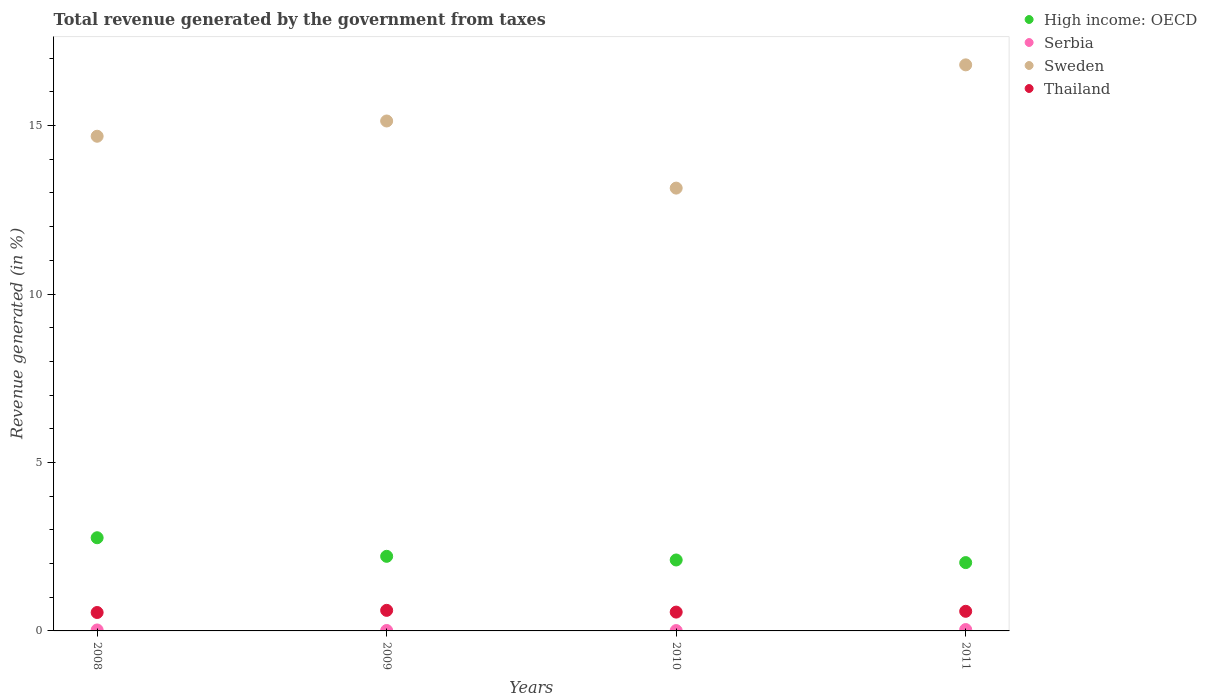How many different coloured dotlines are there?
Ensure brevity in your answer.  4. Is the number of dotlines equal to the number of legend labels?
Provide a succinct answer. Yes. What is the total revenue generated in High income: OECD in 2008?
Keep it short and to the point. 2.77. Across all years, what is the maximum total revenue generated in Thailand?
Ensure brevity in your answer.  0.61. Across all years, what is the minimum total revenue generated in Thailand?
Make the answer very short. 0.55. In which year was the total revenue generated in Thailand minimum?
Provide a short and direct response. 2008. What is the total total revenue generated in Thailand in the graph?
Keep it short and to the point. 2.3. What is the difference between the total revenue generated in Thailand in 2008 and that in 2009?
Your answer should be very brief. -0.06. What is the difference between the total revenue generated in Sweden in 2009 and the total revenue generated in Serbia in 2010?
Provide a short and direct response. 15.13. What is the average total revenue generated in High income: OECD per year?
Make the answer very short. 2.28. In the year 2011, what is the difference between the total revenue generated in Serbia and total revenue generated in Sweden?
Your answer should be compact. -16.76. In how many years, is the total revenue generated in Thailand greater than 10 %?
Give a very brief answer. 0. What is the ratio of the total revenue generated in Serbia in 2010 to that in 2011?
Your response must be concise. 0.26. Is the total revenue generated in Serbia in 2008 less than that in 2011?
Offer a very short reply. Yes. Is the difference between the total revenue generated in Serbia in 2008 and 2009 greater than the difference between the total revenue generated in Sweden in 2008 and 2009?
Provide a short and direct response. Yes. What is the difference between the highest and the second highest total revenue generated in Sweden?
Your response must be concise. 1.67. What is the difference between the highest and the lowest total revenue generated in High income: OECD?
Keep it short and to the point. 0.74. Is the sum of the total revenue generated in Serbia in 2008 and 2010 greater than the maximum total revenue generated in Thailand across all years?
Provide a short and direct response. No. Does the total revenue generated in Thailand monotonically increase over the years?
Your response must be concise. No. Is the total revenue generated in Sweden strictly greater than the total revenue generated in Thailand over the years?
Offer a very short reply. Yes. Is the total revenue generated in Serbia strictly less than the total revenue generated in Thailand over the years?
Make the answer very short. Yes. How many dotlines are there?
Make the answer very short. 4. Does the graph contain grids?
Provide a short and direct response. No. Where does the legend appear in the graph?
Make the answer very short. Top right. What is the title of the graph?
Provide a succinct answer. Total revenue generated by the government from taxes. What is the label or title of the X-axis?
Make the answer very short. Years. What is the label or title of the Y-axis?
Your answer should be very brief. Revenue generated (in %). What is the Revenue generated (in %) of High income: OECD in 2008?
Provide a short and direct response. 2.77. What is the Revenue generated (in %) of Serbia in 2008?
Make the answer very short. 0.03. What is the Revenue generated (in %) in Sweden in 2008?
Your answer should be very brief. 14.68. What is the Revenue generated (in %) in Thailand in 2008?
Provide a short and direct response. 0.55. What is the Revenue generated (in %) in High income: OECD in 2009?
Your answer should be very brief. 2.21. What is the Revenue generated (in %) in Serbia in 2009?
Your answer should be compact. 0.01. What is the Revenue generated (in %) in Sweden in 2009?
Your answer should be compact. 15.14. What is the Revenue generated (in %) of Thailand in 2009?
Keep it short and to the point. 0.61. What is the Revenue generated (in %) in High income: OECD in 2010?
Make the answer very short. 2.11. What is the Revenue generated (in %) in Serbia in 2010?
Your response must be concise. 0.01. What is the Revenue generated (in %) of Sweden in 2010?
Your answer should be compact. 13.14. What is the Revenue generated (in %) in Thailand in 2010?
Make the answer very short. 0.56. What is the Revenue generated (in %) in High income: OECD in 2011?
Give a very brief answer. 2.03. What is the Revenue generated (in %) in Serbia in 2011?
Make the answer very short. 0.04. What is the Revenue generated (in %) in Sweden in 2011?
Your answer should be compact. 16.8. What is the Revenue generated (in %) in Thailand in 2011?
Your response must be concise. 0.58. Across all years, what is the maximum Revenue generated (in %) in High income: OECD?
Provide a short and direct response. 2.77. Across all years, what is the maximum Revenue generated (in %) in Serbia?
Give a very brief answer. 0.04. Across all years, what is the maximum Revenue generated (in %) in Sweden?
Your answer should be compact. 16.8. Across all years, what is the maximum Revenue generated (in %) of Thailand?
Your response must be concise. 0.61. Across all years, what is the minimum Revenue generated (in %) of High income: OECD?
Provide a short and direct response. 2.03. Across all years, what is the minimum Revenue generated (in %) in Serbia?
Keep it short and to the point. 0.01. Across all years, what is the minimum Revenue generated (in %) of Sweden?
Ensure brevity in your answer.  13.14. Across all years, what is the minimum Revenue generated (in %) of Thailand?
Ensure brevity in your answer.  0.55. What is the total Revenue generated (in %) of High income: OECD in the graph?
Ensure brevity in your answer.  9.11. What is the total Revenue generated (in %) in Serbia in the graph?
Give a very brief answer. 0.09. What is the total Revenue generated (in %) of Sweden in the graph?
Keep it short and to the point. 59.76. What is the total Revenue generated (in %) of Thailand in the graph?
Offer a terse response. 2.3. What is the difference between the Revenue generated (in %) of High income: OECD in 2008 and that in 2009?
Your answer should be very brief. 0.55. What is the difference between the Revenue generated (in %) in Serbia in 2008 and that in 2009?
Offer a very short reply. 0.02. What is the difference between the Revenue generated (in %) of Sweden in 2008 and that in 2009?
Offer a terse response. -0.45. What is the difference between the Revenue generated (in %) of Thailand in 2008 and that in 2009?
Provide a short and direct response. -0.06. What is the difference between the Revenue generated (in %) in High income: OECD in 2008 and that in 2010?
Your answer should be very brief. 0.66. What is the difference between the Revenue generated (in %) in Serbia in 2008 and that in 2010?
Your response must be concise. 0.02. What is the difference between the Revenue generated (in %) in Sweden in 2008 and that in 2010?
Your response must be concise. 1.54. What is the difference between the Revenue generated (in %) of Thailand in 2008 and that in 2010?
Your answer should be very brief. -0.01. What is the difference between the Revenue generated (in %) in High income: OECD in 2008 and that in 2011?
Give a very brief answer. 0.74. What is the difference between the Revenue generated (in %) of Serbia in 2008 and that in 2011?
Give a very brief answer. -0.01. What is the difference between the Revenue generated (in %) of Sweden in 2008 and that in 2011?
Provide a succinct answer. -2.12. What is the difference between the Revenue generated (in %) in Thailand in 2008 and that in 2011?
Provide a short and direct response. -0.04. What is the difference between the Revenue generated (in %) in High income: OECD in 2009 and that in 2010?
Provide a succinct answer. 0.11. What is the difference between the Revenue generated (in %) of Serbia in 2009 and that in 2010?
Your answer should be compact. 0. What is the difference between the Revenue generated (in %) in Sweden in 2009 and that in 2010?
Your response must be concise. 1.99. What is the difference between the Revenue generated (in %) in Thailand in 2009 and that in 2010?
Your answer should be compact. 0.05. What is the difference between the Revenue generated (in %) of High income: OECD in 2009 and that in 2011?
Offer a very short reply. 0.19. What is the difference between the Revenue generated (in %) in Serbia in 2009 and that in 2011?
Your answer should be very brief. -0.03. What is the difference between the Revenue generated (in %) of Sweden in 2009 and that in 2011?
Offer a terse response. -1.67. What is the difference between the Revenue generated (in %) of Thailand in 2009 and that in 2011?
Your answer should be very brief. 0.03. What is the difference between the Revenue generated (in %) in High income: OECD in 2010 and that in 2011?
Provide a succinct answer. 0.08. What is the difference between the Revenue generated (in %) of Serbia in 2010 and that in 2011?
Make the answer very short. -0.03. What is the difference between the Revenue generated (in %) of Sweden in 2010 and that in 2011?
Keep it short and to the point. -3.66. What is the difference between the Revenue generated (in %) of Thailand in 2010 and that in 2011?
Make the answer very short. -0.02. What is the difference between the Revenue generated (in %) in High income: OECD in 2008 and the Revenue generated (in %) in Serbia in 2009?
Your answer should be very brief. 2.75. What is the difference between the Revenue generated (in %) of High income: OECD in 2008 and the Revenue generated (in %) of Sweden in 2009?
Keep it short and to the point. -12.37. What is the difference between the Revenue generated (in %) of High income: OECD in 2008 and the Revenue generated (in %) of Thailand in 2009?
Offer a very short reply. 2.16. What is the difference between the Revenue generated (in %) of Serbia in 2008 and the Revenue generated (in %) of Sweden in 2009?
Make the answer very short. -15.11. What is the difference between the Revenue generated (in %) of Serbia in 2008 and the Revenue generated (in %) of Thailand in 2009?
Make the answer very short. -0.58. What is the difference between the Revenue generated (in %) of Sweden in 2008 and the Revenue generated (in %) of Thailand in 2009?
Keep it short and to the point. 14.07. What is the difference between the Revenue generated (in %) of High income: OECD in 2008 and the Revenue generated (in %) of Serbia in 2010?
Give a very brief answer. 2.76. What is the difference between the Revenue generated (in %) of High income: OECD in 2008 and the Revenue generated (in %) of Sweden in 2010?
Keep it short and to the point. -10.38. What is the difference between the Revenue generated (in %) in High income: OECD in 2008 and the Revenue generated (in %) in Thailand in 2010?
Give a very brief answer. 2.21. What is the difference between the Revenue generated (in %) of Serbia in 2008 and the Revenue generated (in %) of Sweden in 2010?
Give a very brief answer. -13.12. What is the difference between the Revenue generated (in %) in Serbia in 2008 and the Revenue generated (in %) in Thailand in 2010?
Keep it short and to the point. -0.53. What is the difference between the Revenue generated (in %) of Sweden in 2008 and the Revenue generated (in %) of Thailand in 2010?
Give a very brief answer. 14.12. What is the difference between the Revenue generated (in %) in High income: OECD in 2008 and the Revenue generated (in %) in Serbia in 2011?
Offer a terse response. 2.73. What is the difference between the Revenue generated (in %) of High income: OECD in 2008 and the Revenue generated (in %) of Sweden in 2011?
Provide a succinct answer. -14.04. What is the difference between the Revenue generated (in %) of High income: OECD in 2008 and the Revenue generated (in %) of Thailand in 2011?
Make the answer very short. 2.18. What is the difference between the Revenue generated (in %) in Serbia in 2008 and the Revenue generated (in %) in Sweden in 2011?
Provide a short and direct response. -16.77. What is the difference between the Revenue generated (in %) in Serbia in 2008 and the Revenue generated (in %) in Thailand in 2011?
Provide a short and direct response. -0.55. What is the difference between the Revenue generated (in %) of Sweden in 2008 and the Revenue generated (in %) of Thailand in 2011?
Offer a very short reply. 14.1. What is the difference between the Revenue generated (in %) in High income: OECD in 2009 and the Revenue generated (in %) in Serbia in 2010?
Provide a short and direct response. 2.2. What is the difference between the Revenue generated (in %) in High income: OECD in 2009 and the Revenue generated (in %) in Sweden in 2010?
Your response must be concise. -10.93. What is the difference between the Revenue generated (in %) in High income: OECD in 2009 and the Revenue generated (in %) in Thailand in 2010?
Provide a succinct answer. 1.66. What is the difference between the Revenue generated (in %) of Serbia in 2009 and the Revenue generated (in %) of Sweden in 2010?
Your answer should be very brief. -13.13. What is the difference between the Revenue generated (in %) of Serbia in 2009 and the Revenue generated (in %) of Thailand in 2010?
Provide a short and direct response. -0.55. What is the difference between the Revenue generated (in %) of Sweden in 2009 and the Revenue generated (in %) of Thailand in 2010?
Your answer should be very brief. 14.58. What is the difference between the Revenue generated (in %) of High income: OECD in 2009 and the Revenue generated (in %) of Serbia in 2011?
Your answer should be very brief. 2.17. What is the difference between the Revenue generated (in %) in High income: OECD in 2009 and the Revenue generated (in %) in Sweden in 2011?
Provide a succinct answer. -14.59. What is the difference between the Revenue generated (in %) of High income: OECD in 2009 and the Revenue generated (in %) of Thailand in 2011?
Your response must be concise. 1.63. What is the difference between the Revenue generated (in %) in Serbia in 2009 and the Revenue generated (in %) in Sweden in 2011?
Your answer should be compact. -16.79. What is the difference between the Revenue generated (in %) in Serbia in 2009 and the Revenue generated (in %) in Thailand in 2011?
Offer a very short reply. -0.57. What is the difference between the Revenue generated (in %) in Sweden in 2009 and the Revenue generated (in %) in Thailand in 2011?
Offer a very short reply. 14.55. What is the difference between the Revenue generated (in %) of High income: OECD in 2010 and the Revenue generated (in %) of Serbia in 2011?
Your answer should be compact. 2.06. What is the difference between the Revenue generated (in %) in High income: OECD in 2010 and the Revenue generated (in %) in Sweden in 2011?
Provide a short and direct response. -14.7. What is the difference between the Revenue generated (in %) in High income: OECD in 2010 and the Revenue generated (in %) in Thailand in 2011?
Provide a short and direct response. 1.52. What is the difference between the Revenue generated (in %) in Serbia in 2010 and the Revenue generated (in %) in Sweden in 2011?
Give a very brief answer. -16.79. What is the difference between the Revenue generated (in %) in Serbia in 2010 and the Revenue generated (in %) in Thailand in 2011?
Your answer should be compact. -0.57. What is the difference between the Revenue generated (in %) of Sweden in 2010 and the Revenue generated (in %) of Thailand in 2011?
Keep it short and to the point. 12.56. What is the average Revenue generated (in %) of High income: OECD per year?
Provide a succinct answer. 2.28. What is the average Revenue generated (in %) of Serbia per year?
Provide a short and direct response. 0.02. What is the average Revenue generated (in %) of Sweden per year?
Your answer should be very brief. 14.94. What is the average Revenue generated (in %) in Thailand per year?
Your answer should be compact. 0.57. In the year 2008, what is the difference between the Revenue generated (in %) in High income: OECD and Revenue generated (in %) in Serbia?
Provide a short and direct response. 2.74. In the year 2008, what is the difference between the Revenue generated (in %) in High income: OECD and Revenue generated (in %) in Sweden?
Your response must be concise. -11.92. In the year 2008, what is the difference between the Revenue generated (in %) of High income: OECD and Revenue generated (in %) of Thailand?
Give a very brief answer. 2.22. In the year 2008, what is the difference between the Revenue generated (in %) of Serbia and Revenue generated (in %) of Sweden?
Ensure brevity in your answer.  -14.65. In the year 2008, what is the difference between the Revenue generated (in %) of Serbia and Revenue generated (in %) of Thailand?
Your answer should be very brief. -0.52. In the year 2008, what is the difference between the Revenue generated (in %) in Sweden and Revenue generated (in %) in Thailand?
Make the answer very short. 14.14. In the year 2009, what is the difference between the Revenue generated (in %) in High income: OECD and Revenue generated (in %) in Serbia?
Provide a short and direct response. 2.2. In the year 2009, what is the difference between the Revenue generated (in %) of High income: OECD and Revenue generated (in %) of Sweden?
Give a very brief answer. -12.92. In the year 2009, what is the difference between the Revenue generated (in %) of High income: OECD and Revenue generated (in %) of Thailand?
Offer a terse response. 1.6. In the year 2009, what is the difference between the Revenue generated (in %) of Serbia and Revenue generated (in %) of Sweden?
Ensure brevity in your answer.  -15.12. In the year 2009, what is the difference between the Revenue generated (in %) of Serbia and Revenue generated (in %) of Thailand?
Make the answer very short. -0.6. In the year 2009, what is the difference between the Revenue generated (in %) in Sweden and Revenue generated (in %) in Thailand?
Offer a very short reply. 14.53. In the year 2010, what is the difference between the Revenue generated (in %) of High income: OECD and Revenue generated (in %) of Serbia?
Your answer should be very brief. 2.1. In the year 2010, what is the difference between the Revenue generated (in %) of High income: OECD and Revenue generated (in %) of Sweden?
Your answer should be very brief. -11.04. In the year 2010, what is the difference between the Revenue generated (in %) of High income: OECD and Revenue generated (in %) of Thailand?
Your answer should be compact. 1.55. In the year 2010, what is the difference between the Revenue generated (in %) of Serbia and Revenue generated (in %) of Sweden?
Make the answer very short. -13.13. In the year 2010, what is the difference between the Revenue generated (in %) of Serbia and Revenue generated (in %) of Thailand?
Your answer should be compact. -0.55. In the year 2010, what is the difference between the Revenue generated (in %) in Sweden and Revenue generated (in %) in Thailand?
Offer a terse response. 12.58. In the year 2011, what is the difference between the Revenue generated (in %) of High income: OECD and Revenue generated (in %) of Serbia?
Offer a very short reply. 1.99. In the year 2011, what is the difference between the Revenue generated (in %) in High income: OECD and Revenue generated (in %) in Sweden?
Your response must be concise. -14.77. In the year 2011, what is the difference between the Revenue generated (in %) in High income: OECD and Revenue generated (in %) in Thailand?
Ensure brevity in your answer.  1.45. In the year 2011, what is the difference between the Revenue generated (in %) in Serbia and Revenue generated (in %) in Sweden?
Your answer should be very brief. -16.76. In the year 2011, what is the difference between the Revenue generated (in %) in Serbia and Revenue generated (in %) in Thailand?
Provide a short and direct response. -0.54. In the year 2011, what is the difference between the Revenue generated (in %) in Sweden and Revenue generated (in %) in Thailand?
Your answer should be compact. 16.22. What is the ratio of the Revenue generated (in %) in High income: OECD in 2008 to that in 2009?
Ensure brevity in your answer.  1.25. What is the ratio of the Revenue generated (in %) of Serbia in 2008 to that in 2009?
Offer a very short reply. 2.18. What is the ratio of the Revenue generated (in %) in Sweden in 2008 to that in 2009?
Make the answer very short. 0.97. What is the ratio of the Revenue generated (in %) of Thailand in 2008 to that in 2009?
Your answer should be very brief. 0.9. What is the ratio of the Revenue generated (in %) in High income: OECD in 2008 to that in 2010?
Offer a very short reply. 1.31. What is the ratio of the Revenue generated (in %) in Serbia in 2008 to that in 2010?
Keep it short and to the point. 2.74. What is the ratio of the Revenue generated (in %) in Sweden in 2008 to that in 2010?
Provide a short and direct response. 1.12. What is the ratio of the Revenue generated (in %) of Thailand in 2008 to that in 2010?
Your response must be concise. 0.98. What is the ratio of the Revenue generated (in %) in High income: OECD in 2008 to that in 2011?
Offer a terse response. 1.36. What is the ratio of the Revenue generated (in %) of Serbia in 2008 to that in 2011?
Ensure brevity in your answer.  0.7. What is the ratio of the Revenue generated (in %) of Sweden in 2008 to that in 2011?
Provide a short and direct response. 0.87. What is the ratio of the Revenue generated (in %) in Thailand in 2008 to that in 2011?
Give a very brief answer. 0.94. What is the ratio of the Revenue generated (in %) in High income: OECD in 2009 to that in 2010?
Your answer should be very brief. 1.05. What is the ratio of the Revenue generated (in %) in Serbia in 2009 to that in 2010?
Your answer should be very brief. 1.25. What is the ratio of the Revenue generated (in %) in Sweden in 2009 to that in 2010?
Ensure brevity in your answer.  1.15. What is the ratio of the Revenue generated (in %) in Thailand in 2009 to that in 2010?
Give a very brief answer. 1.09. What is the ratio of the Revenue generated (in %) of High income: OECD in 2009 to that in 2011?
Provide a succinct answer. 1.09. What is the ratio of the Revenue generated (in %) of Serbia in 2009 to that in 2011?
Your response must be concise. 0.32. What is the ratio of the Revenue generated (in %) in Sweden in 2009 to that in 2011?
Your response must be concise. 0.9. What is the ratio of the Revenue generated (in %) in Thailand in 2009 to that in 2011?
Your answer should be very brief. 1.05. What is the ratio of the Revenue generated (in %) of High income: OECD in 2010 to that in 2011?
Offer a very short reply. 1.04. What is the ratio of the Revenue generated (in %) in Serbia in 2010 to that in 2011?
Your answer should be compact. 0.26. What is the ratio of the Revenue generated (in %) of Sweden in 2010 to that in 2011?
Make the answer very short. 0.78. What is the ratio of the Revenue generated (in %) of Thailand in 2010 to that in 2011?
Keep it short and to the point. 0.96. What is the difference between the highest and the second highest Revenue generated (in %) in High income: OECD?
Keep it short and to the point. 0.55. What is the difference between the highest and the second highest Revenue generated (in %) in Serbia?
Provide a short and direct response. 0.01. What is the difference between the highest and the second highest Revenue generated (in %) of Sweden?
Your answer should be compact. 1.67. What is the difference between the highest and the second highest Revenue generated (in %) in Thailand?
Your response must be concise. 0.03. What is the difference between the highest and the lowest Revenue generated (in %) of High income: OECD?
Keep it short and to the point. 0.74. What is the difference between the highest and the lowest Revenue generated (in %) of Serbia?
Your answer should be compact. 0.03. What is the difference between the highest and the lowest Revenue generated (in %) in Sweden?
Keep it short and to the point. 3.66. What is the difference between the highest and the lowest Revenue generated (in %) in Thailand?
Provide a short and direct response. 0.06. 